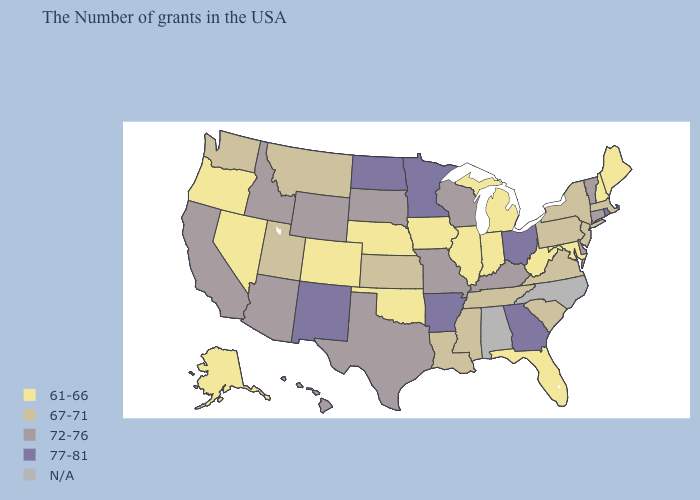Name the states that have a value in the range N/A?
Answer briefly. North Carolina, Alabama. Name the states that have a value in the range N/A?
Keep it brief. North Carolina, Alabama. Among the states that border Minnesota , which have the lowest value?
Keep it brief. Iowa. Name the states that have a value in the range 61-66?
Be succinct. Maine, New Hampshire, Maryland, West Virginia, Florida, Michigan, Indiana, Illinois, Iowa, Nebraska, Oklahoma, Colorado, Nevada, Oregon, Alaska. Which states have the highest value in the USA?
Concise answer only. Rhode Island, Ohio, Georgia, Arkansas, Minnesota, North Dakota, New Mexico. What is the value of Ohio?
Keep it brief. 77-81. Name the states that have a value in the range N/A?
Answer briefly. North Carolina, Alabama. What is the lowest value in the USA?
Short answer required. 61-66. What is the value of Massachusetts?
Give a very brief answer. 67-71. What is the value of Alabama?
Answer briefly. N/A. Does Wyoming have the lowest value in the USA?
Give a very brief answer. No. What is the highest value in the USA?
Give a very brief answer. 77-81. Does the first symbol in the legend represent the smallest category?
Write a very short answer. Yes. Which states have the highest value in the USA?
Keep it brief. Rhode Island, Ohio, Georgia, Arkansas, Minnesota, North Dakota, New Mexico. Name the states that have a value in the range 67-71?
Concise answer only. Massachusetts, New York, New Jersey, Pennsylvania, Virginia, South Carolina, Tennessee, Mississippi, Louisiana, Kansas, Utah, Montana, Washington. 